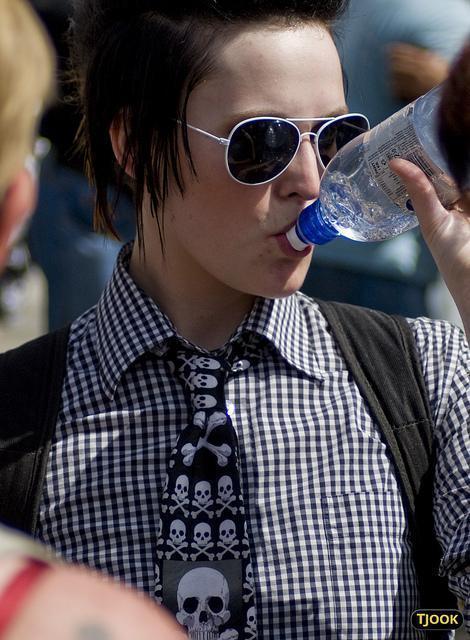How many bottles can be seen?
Give a very brief answer. 1. How many people are there?
Give a very brief answer. 3. How many boats are in the water?
Give a very brief answer. 0. 